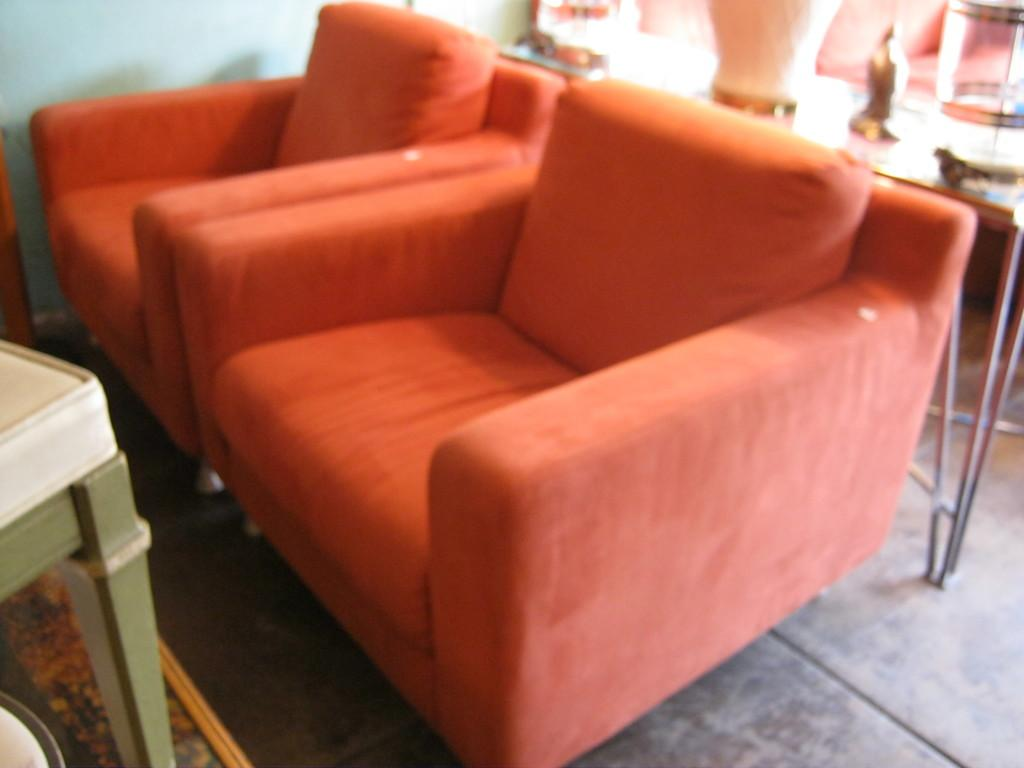How many sofa chairs are in the image? There are two sofa chairs in the image. What else can be seen in the background of the image? There is a table visible in the background of the image. What thought is expressed by the box in the image? There is no box present in the image, so it cannot express any thoughts. 